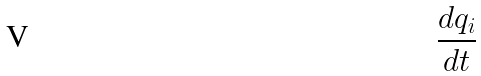<formula> <loc_0><loc_0><loc_500><loc_500>\frac { d q _ { i } } { d t }</formula> 